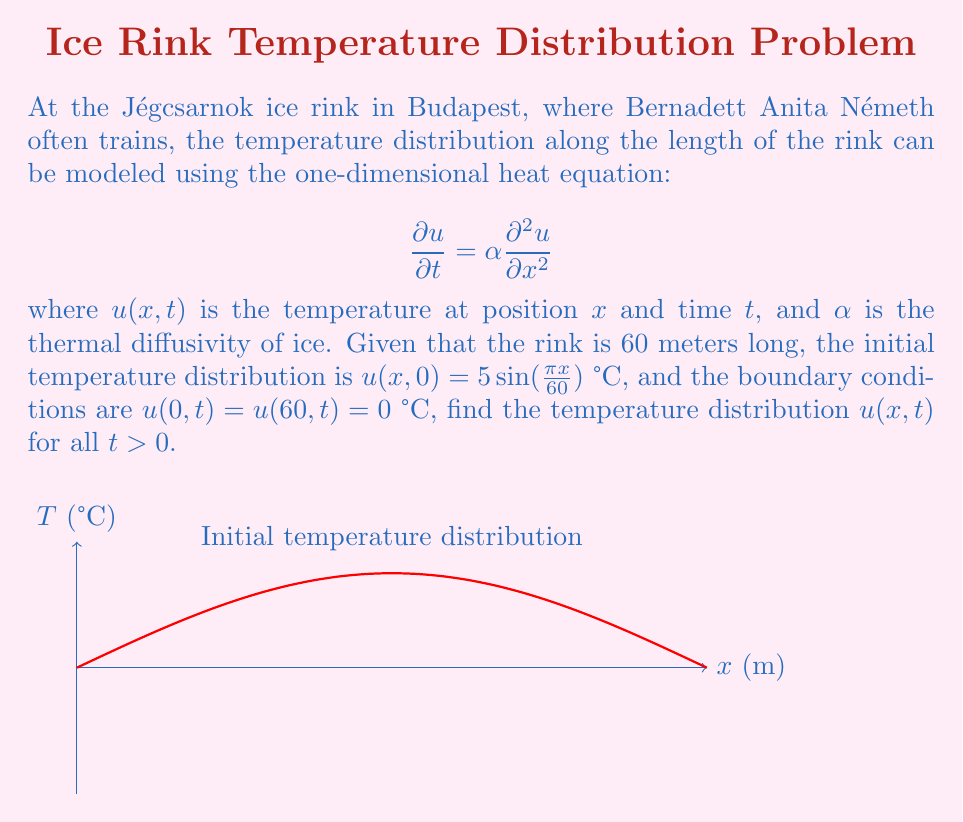Provide a solution to this math problem. To solve this problem, we'll use the method of separation of variables:

1) Assume $u(x,t) = X(x)T(t)$

2) Substitute into the heat equation:
   $$X(x)T'(t) = \alpha X''(x)T(t)$$

3) Separate variables:
   $$\frac{T'(t)}{T(t)} = \alpha \frac{X''(x)}{X(x)} = -\lambda$$
   where $-\lambda$ is a separation constant.

4) Solve the spatial equation:
   $$X''(x) + \frac{\lambda}{\alpha}X(x) = 0$$
   With boundary conditions $X(0) = X(60) = 0$, we get:
   $$X_n(x) = \sin(\frac{n\pi x}{60}), \quad \lambda_n = (\frac{n\pi}{60})^2\alpha, \quad n = 1,2,3,...$$

5) Solve the temporal equation:
   $$T_n(t) = e^{-\lambda_n t} = e^{-(\frac{n\pi}{60})^2\alpha t}$$

6) The general solution is:
   $$u(x,t) = \sum_{n=1}^{\infty} c_n \sin(\frac{n\pi x}{60}) e^{-(\frac{n\pi}{60})^2\alpha t}$$

7) Apply the initial condition:
   $$5 \sin(\frac{\pi x}{60}) = \sum_{n=1}^{\infty} c_n \sin(\frac{n\pi x}{60})$$

8) By orthogonality of sine functions, we find that $c_1 = 5$ and $c_n = 0$ for $n > 1$

Therefore, the final solution is:
$$u(x,t) = 5 \sin(\frac{\pi x}{60}) e^{-(\frac{\pi}{60})^2\alpha t}$$
Answer: $u(x,t) = 5 \sin(\frac{\pi x}{60}) e^{-(\frac{\pi}{60})^2\alpha t}$ 